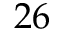Convert formula to latex. <formula><loc_0><loc_0><loc_500><loc_500>2 6</formula> 